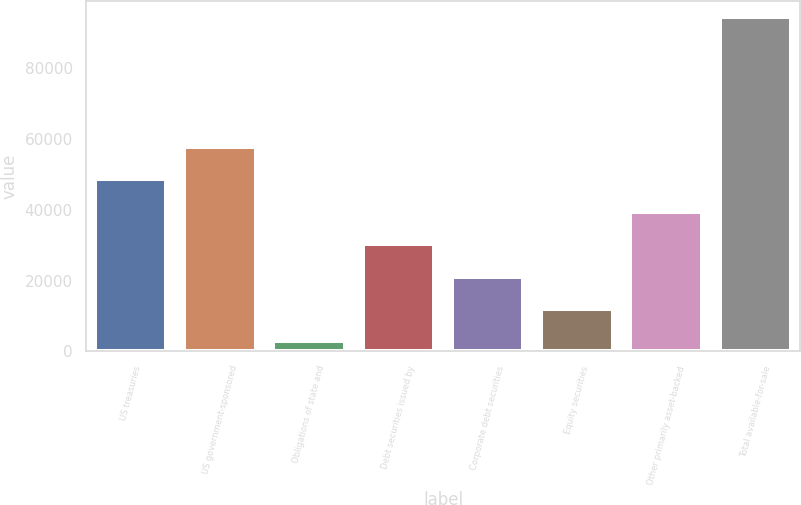Convert chart. <chart><loc_0><loc_0><loc_500><loc_500><bar_chart><fcel>US treasuries<fcel>US government-sponsored<fcel>Obligations of state and<fcel>Debt securities issued by<fcel>Corporate debt securities<fcel>Equity securities<fcel>Other primarily asset-backed<fcel>Total available-for-sale<nl><fcel>48634<fcel>57787.6<fcel>2866<fcel>30326.8<fcel>21173.2<fcel>12019.6<fcel>39480.4<fcel>94402<nl></chart> 